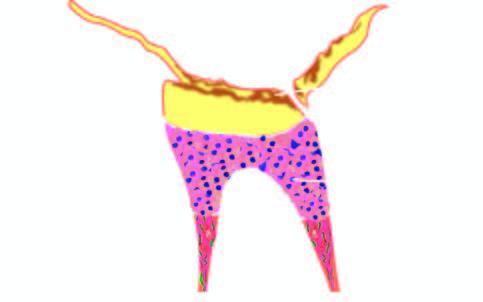s normal non-activated platelet, having open canalicular system and the cytoplasmic organelles complete destruction of enamel, deposition of secondary dentine and evidence of pulpitis?
Answer the question using a single word or phrase. No 